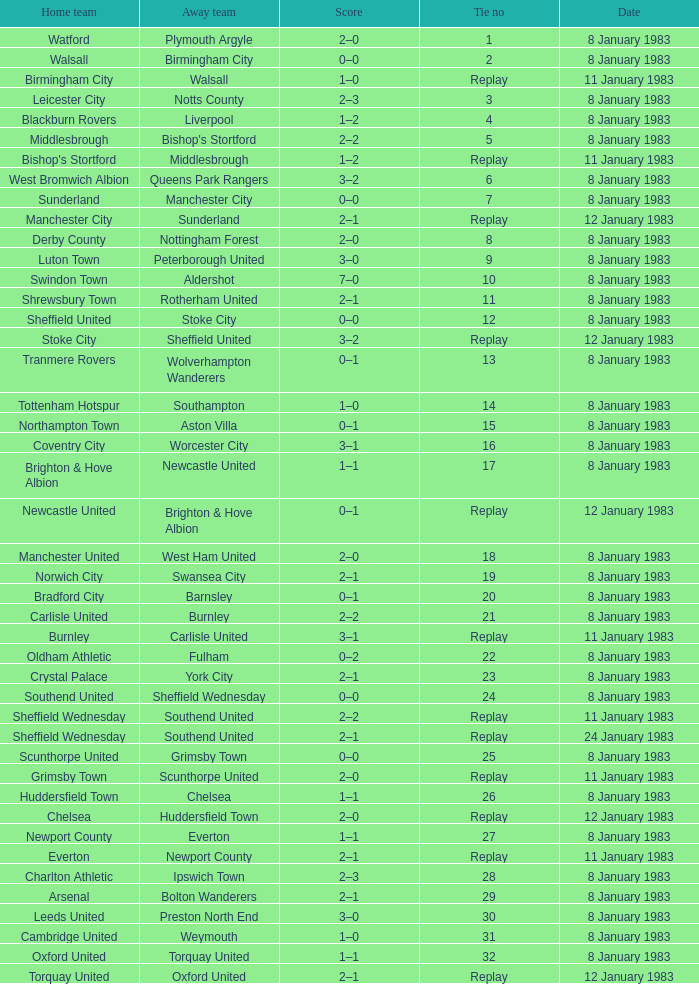What was the final score for the tie where Leeds United was the home team? 3–0. 